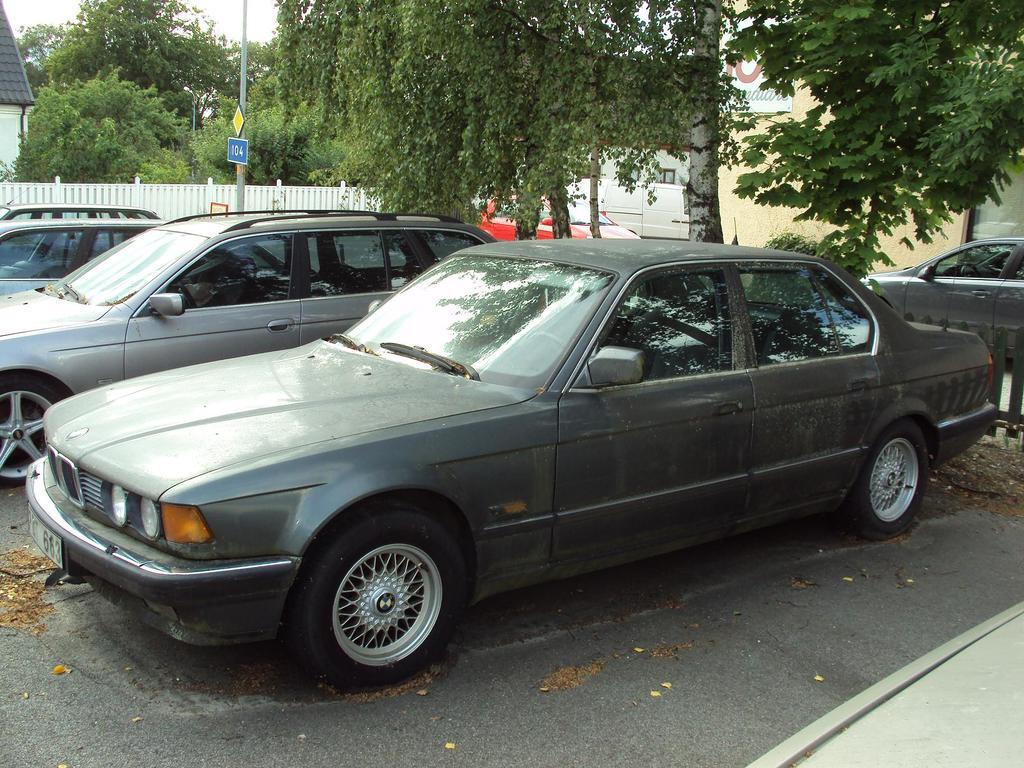What can be seen on the road in the image? There are cars on the road in the image. What are the boards attached to in the image? The boards are on poles in the image. What type of vegetation is visible in the image? There are trees visible in the image. What type of structure is present in the image? There is a house in the image. What type of barrier is present in the image? There is a fence in the image. Where is another board located in the image? There is a board on a wall in the image. What is visible in the background of the image? The sky is visible in the background of the image. What smell can be detected from the chalk in the image? There is no chalk present in the image, so no smell can be detected from it. 